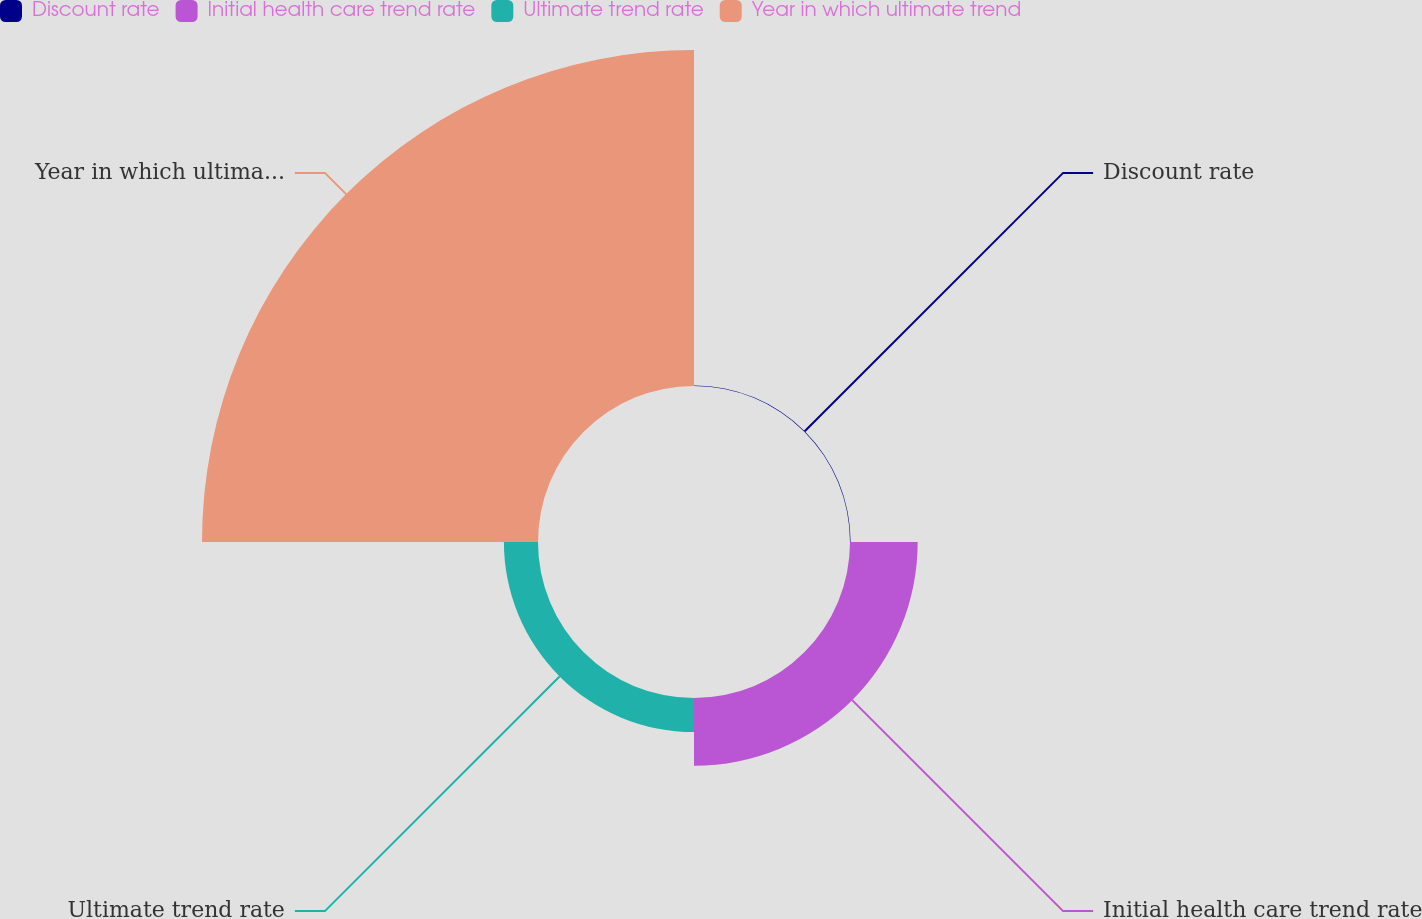Convert chart. <chart><loc_0><loc_0><loc_500><loc_500><pie_chart><fcel>Discount rate<fcel>Initial health care trend rate<fcel>Ultimate trend rate<fcel>Year in which ultimate trend<nl><fcel>0.13%<fcel>15.44%<fcel>7.78%<fcel>76.65%<nl></chart> 